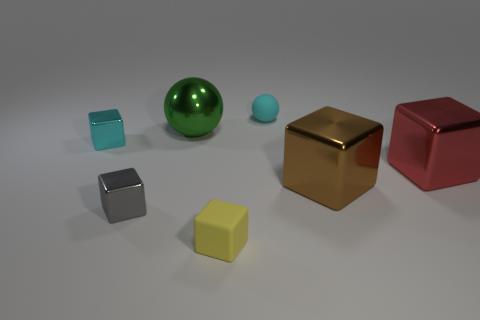Subtract all small yellow blocks. How many blocks are left? 4 Subtract all red blocks. How many blocks are left? 4 Subtract all blue cubes. Subtract all gray balls. How many cubes are left? 5 Add 1 small gray things. How many objects exist? 8 Subtract all blocks. How many objects are left? 2 Subtract all small gray metal spheres. Subtract all balls. How many objects are left? 5 Add 4 tiny objects. How many tiny objects are left? 8 Add 7 tiny gray things. How many tiny gray things exist? 8 Subtract 0 brown balls. How many objects are left? 7 